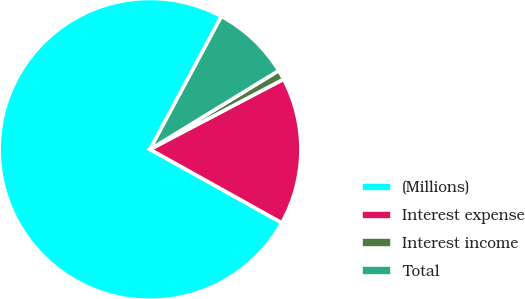Convert chart. <chart><loc_0><loc_0><loc_500><loc_500><pie_chart><fcel>(Millions)<fcel>Interest expense<fcel>Interest income<fcel>Total<nl><fcel>74.75%<fcel>15.79%<fcel>1.04%<fcel>8.42%<nl></chart> 